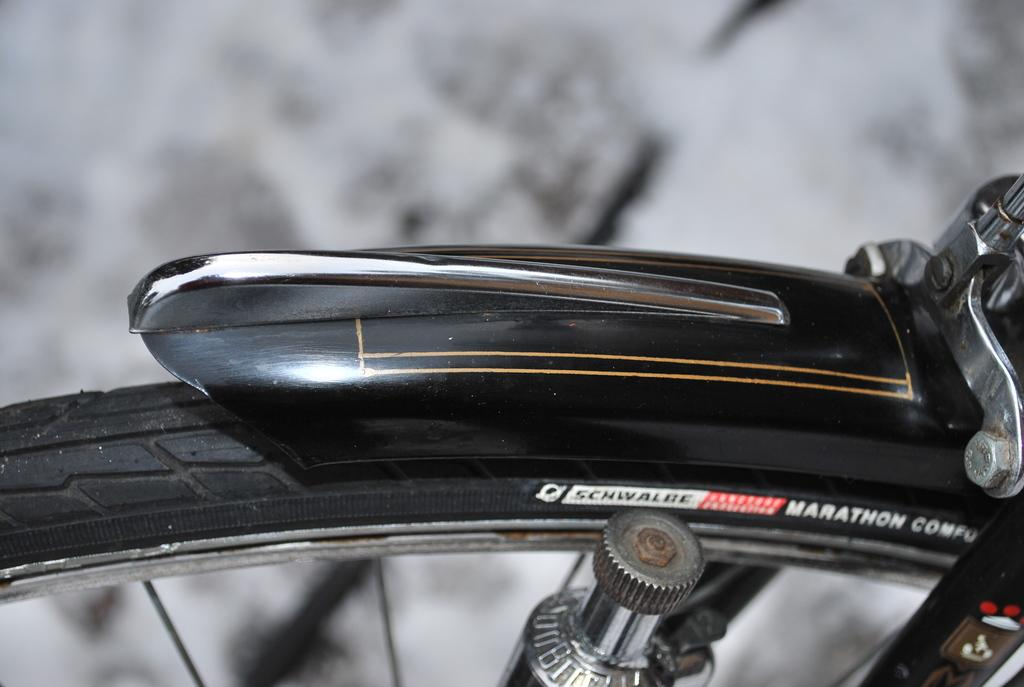What is the main subject of the image? The main subject of the image is a black bicycle wheel. Are there any additional features on the bicycle wheel? Yes, there is writing on the bicycle wheel. What can be observed about the background of the image? The background of the image is blurred. What type of shoe is being worn by the soldier in the image? There is no soldier or shoe present in the image; it features a black bicycle wheel with writing on it. What company is responsible for manufacturing the bicycle wheel in the image? The image does not provide information about the manufacturer of the bicycle wheel. 